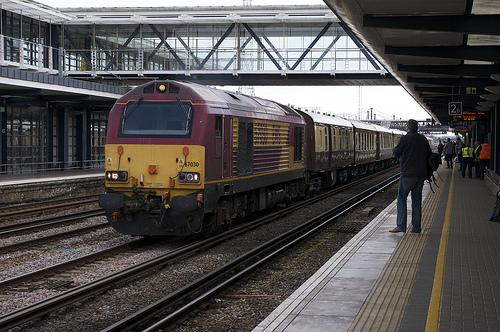Identify the primary objects in the image and their current situations. A man waiting at the platform, a red and yellow train stationed, and an overhead walkway crossing the tracks. Describe the main components of the image and their positions. The image features a train platform with a man waiting, a red and yellow train on the tracks, and a walkway above. Mention the main elements in the image and their locations. There is a man on the platform, a red and yellow train arriving, and an overhead walkway crossing above the tracks. Narrate the key visual elements and their interactions in the image. A man stands at a train platform as a red and yellow train approaches, with an overhead walkway crossing the tracks. Briefly explain the primary focus of the image and its current action. A man waits at a train platform as a red and yellow train arrives at the station. Provide a simple description of the scene captured in the image. A train station with a red and yellow train, a man waiting on the platform, and a walkway above the tracks. Provide a quick overview of the main subjects in the image and their actions. A red and yellow train at a station, a man waiting on the platform, and a walkway connecting both sides. Write a concise summary of the most noticeable features in the image. Man waiting on platform, red and yellow train arriving, overhead walkway, and multiple tracks. In one sentence, describe the central theme of the image. The image portrays a man waiting at a train station as a red and yellow train arrives. Mention the most prominent elements in the image and their activities. A man waits at a platform, a red and yellow train approaches, and an overhead walkway connects the station sides. 